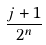Convert formula to latex. <formula><loc_0><loc_0><loc_500><loc_500>\frac { j + 1 } { 2 ^ { n } }</formula> 